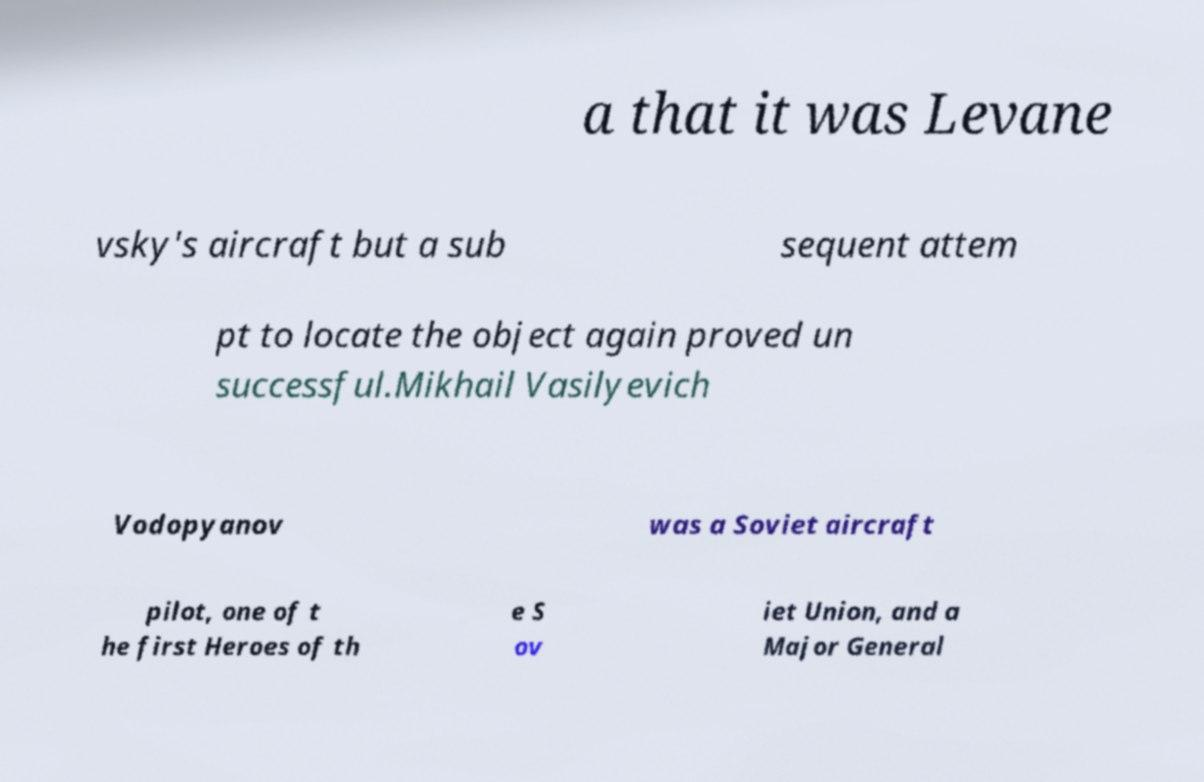Could you extract and type out the text from this image? a that it was Levane vsky's aircraft but a sub sequent attem pt to locate the object again proved un successful.Mikhail Vasilyevich Vodopyanov was a Soviet aircraft pilot, one of t he first Heroes of th e S ov iet Union, and a Major General 